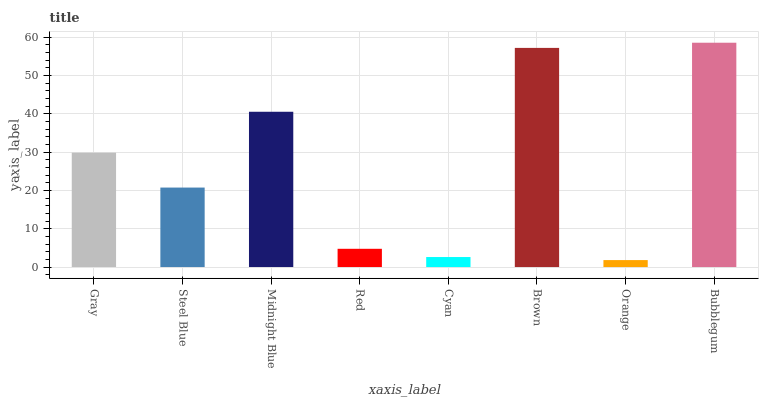Is Orange the minimum?
Answer yes or no. Yes. Is Bubblegum the maximum?
Answer yes or no. Yes. Is Steel Blue the minimum?
Answer yes or no. No. Is Steel Blue the maximum?
Answer yes or no. No. Is Gray greater than Steel Blue?
Answer yes or no. Yes. Is Steel Blue less than Gray?
Answer yes or no. Yes. Is Steel Blue greater than Gray?
Answer yes or no. No. Is Gray less than Steel Blue?
Answer yes or no. No. Is Gray the high median?
Answer yes or no. Yes. Is Steel Blue the low median?
Answer yes or no. Yes. Is Bubblegum the high median?
Answer yes or no. No. Is Bubblegum the low median?
Answer yes or no. No. 